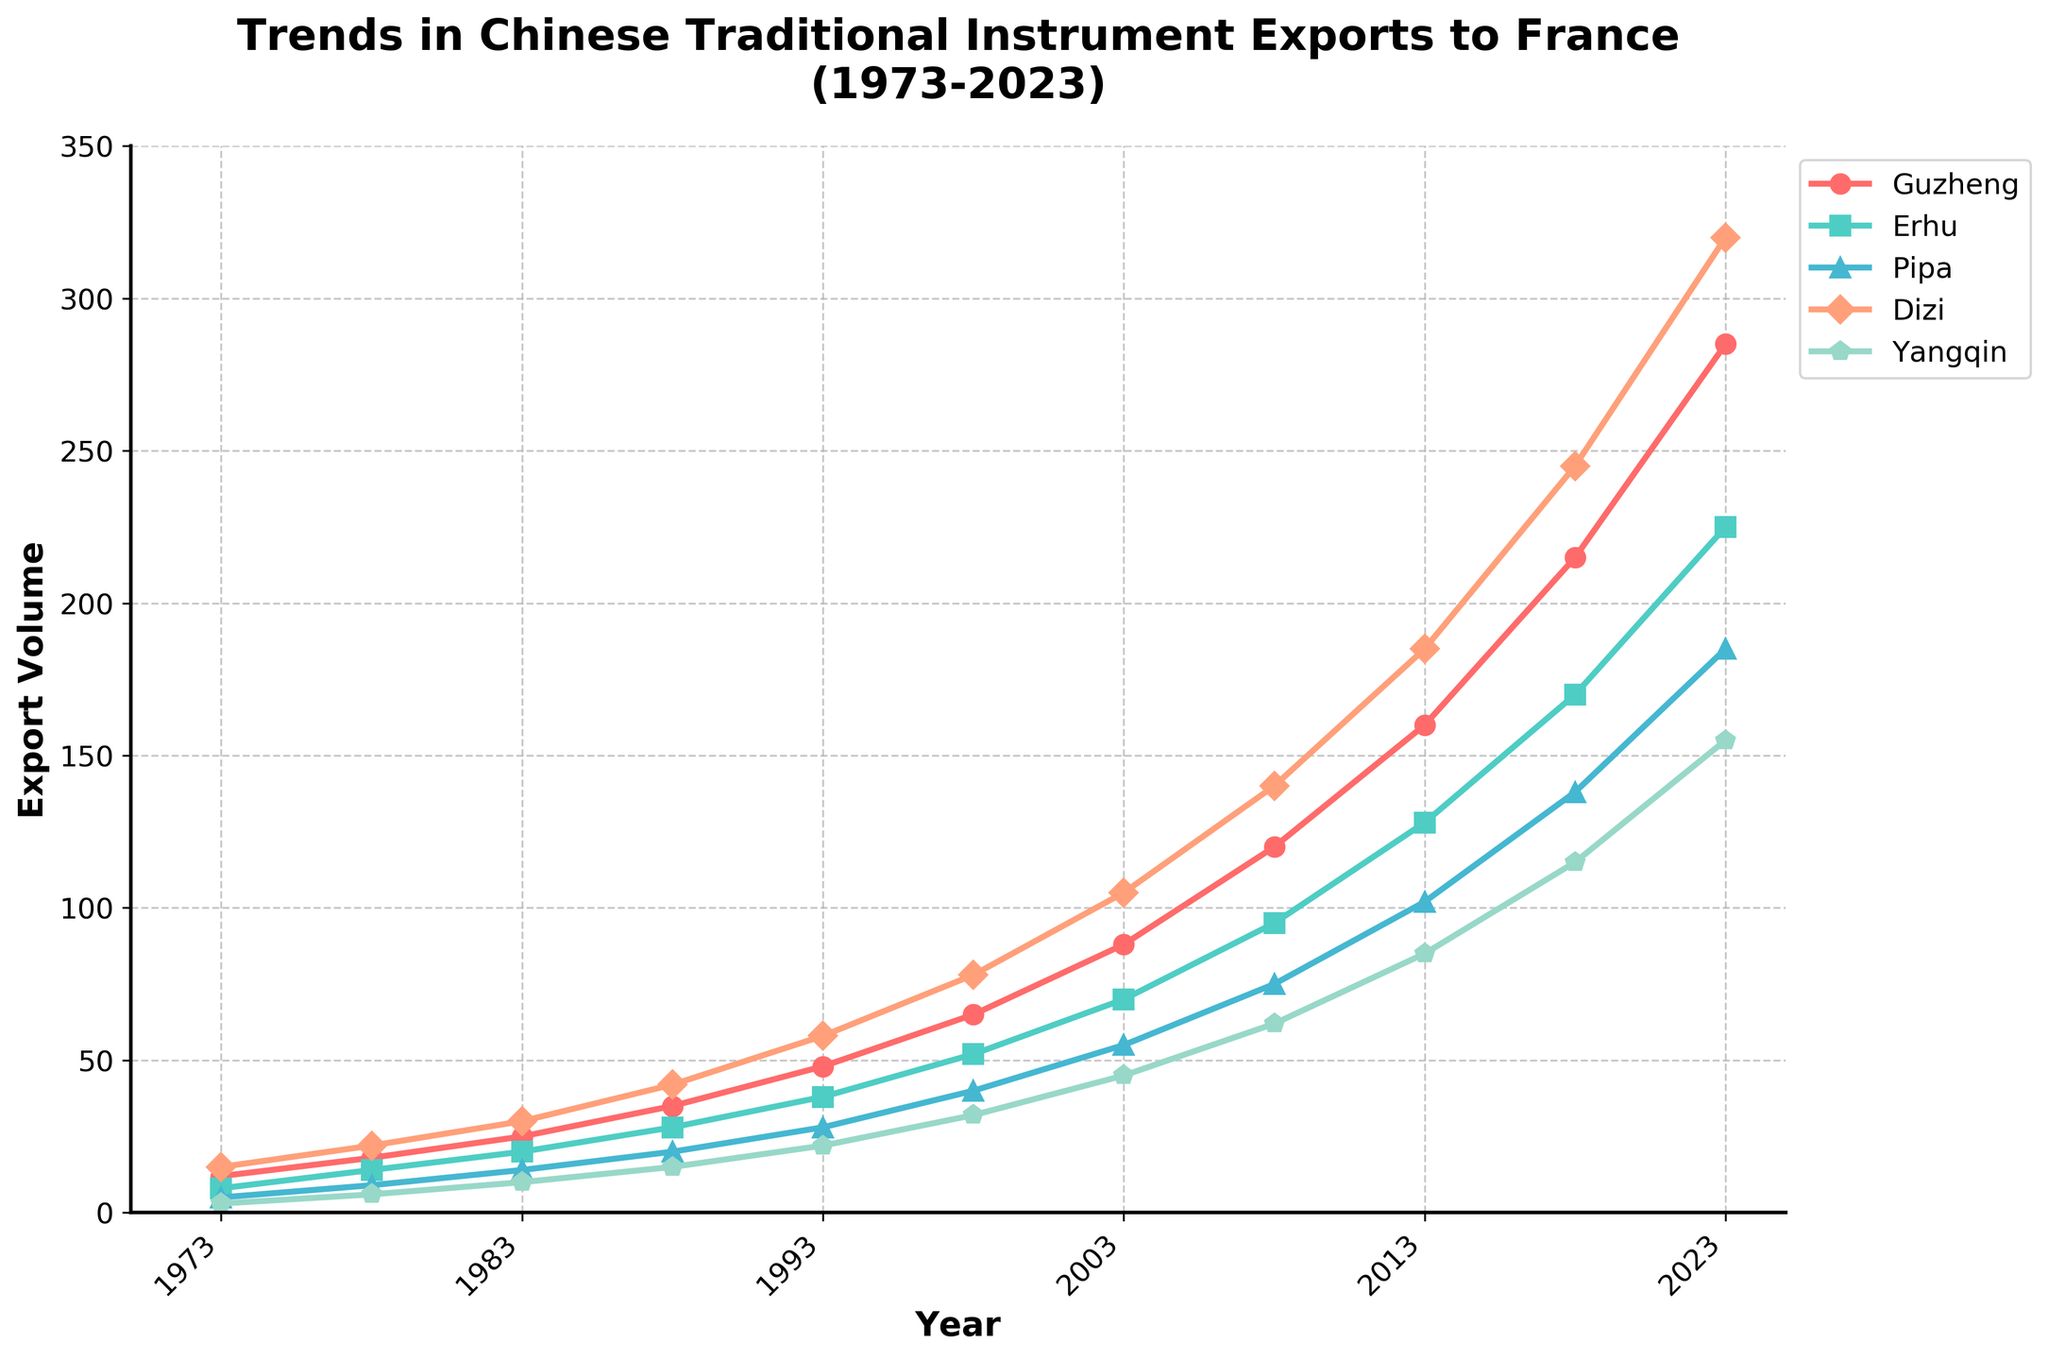What year had the highest export volume of Guzheng? The highest export volume of Guzheng can be found by identifying the peak of the red line on the chart. We observe that in the year 2023, the red line reaches its highest point.
Answer: 2023 Which instrument had the smallest export volume in 1973, and what was its value? To find the smallest export volume in 1973, we compare all instrument values in that year. Guzheng: 12, Erhu: 8, Pipa: 5, Dizi: 15, Yangqin: 3. Yangqin has the smallest value, which is 3.
Answer: Yangqin, 3 How did the export volume of Dizi change from 1973 to 2023? By subtracting the export volume of Dizi in 1973 from its volume in 2023, we find the change. Dizi in 1973: 15, Dizi in 2023: 320. The change is 320 - 15 = 305.
Answer: Increased by 305 What was the average export volume of Erhu in the years 1983 and 1988? First, we add the Erhu export volumes for 1983 and 1988: 20 + 28. Then, we divide the sum by 2 to get the average. (20 + 28) / 2 = 24.
Answer: 24 Which instrument saw the greatest increase in export volume between 2003 and 2013? We calculate the increase for each instrument between 2003 and 2013: Guzheng: 160 - 88 = 72, Erhu: 128 - 70 = 58, Pipa: 102 - 55 = 47, Dizi: 185 - 105 = 80, Yangqin: 85 - 45 = 40. Dizi saw the greatest increase of 80.
Answer: Dizi What is the combined export volume of Pipa and Yangqin in 2023? We sum the export volumes of Pipa and Yangqin in the year 2023: 185 + 155 = 340.
Answer: 340 Which instrument's export volume was greater in 1988, Pipa or Yangqin? By comparing the Pipa and Yangqin export volumes in 1988, we see Pipa: 20 and Yangqin: 15. Pipa has a greater export volume.
Answer: Pipa Approximately how much did the Guzheng export volume increase every five years on average from 1973 to 2023? Total increase in Guzheng export volume from 1973 to 2023 is 285 - 12 = 273. There are 50 years (10 periods of 5 years each) between 1973 and 2023. So, the average increase per 5 years is 273 / 10 = 27.3.
Answer: 27.3 Which year did the Dizi export volume first exceed 100 units? By examining the Dizi export trend, we find the export volume first exceeded 100 units in 2003 as the values in earlier years were below 100 and in 2003 it reached 105.
Answer: 2003 